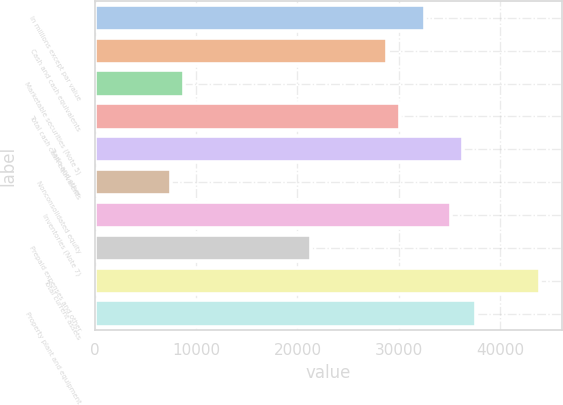<chart> <loc_0><loc_0><loc_500><loc_500><bar_chart><fcel>In millions except par value<fcel>Cash and cash equivalents<fcel>Marketable securities (Note 5)<fcel>Total cash cash equivalents<fcel>Trade and other<fcel>Nonconsolidated equity<fcel>Inventories (Note 7)<fcel>Prepaid expenses and other<fcel>Total current assets<fcel>Property plant and equipment<nl><fcel>32599.2<fcel>28839.6<fcel>8788.4<fcel>30092.8<fcel>36358.8<fcel>7535.2<fcel>35105.6<fcel>21320.4<fcel>43878<fcel>37612<nl></chart> 